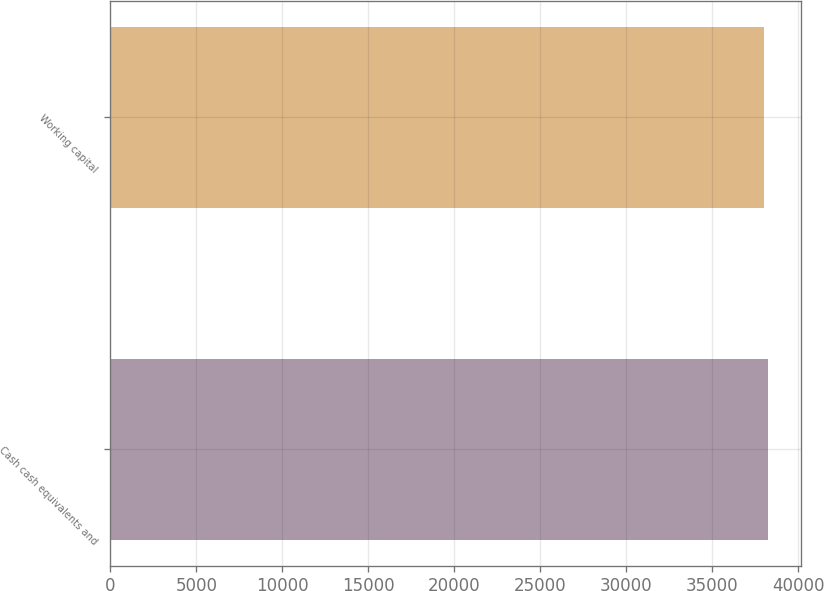<chart> <loc_0><loc_0><loc_500><loc_500><bar_chart><fcel>Cash cash equivalents and<fcel>Working capital<nl><fcel>38246<fcel>38021<nl></chart> 